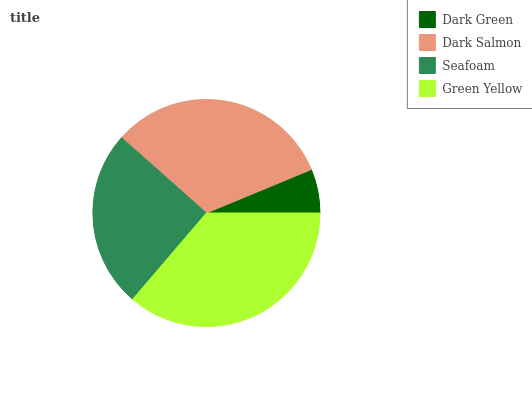Is Dark Green the minimum?
Answer yes or no. Yes. Is Green Yellow the maximum?
Answer yes or no. Yes. Is Dark Salmon the minimum?
Answer yes or no. No. Is Dark Salmon the maximum?
Answer yes or no. No. Is Dark Salmon greater than Dark Green?
Answer yes or no. Yes. Is Dark Green less than Dark Salmon?
Answer yes or no. Yes. Is Dark Green greater than Dark Salmon?
Answer yes or no. No. Is Dark Salmon less than Dark Green?
Answer yes or no. No. Is Dark Salmon the high median?
Answer yes or no. Yes. Is Seafoam the low median?
Answer yes or no. Yes. Is Seafoam the high median?
Answer yes or no. No. Is Dark Salmon the low median?
Answer yes or no. No. 